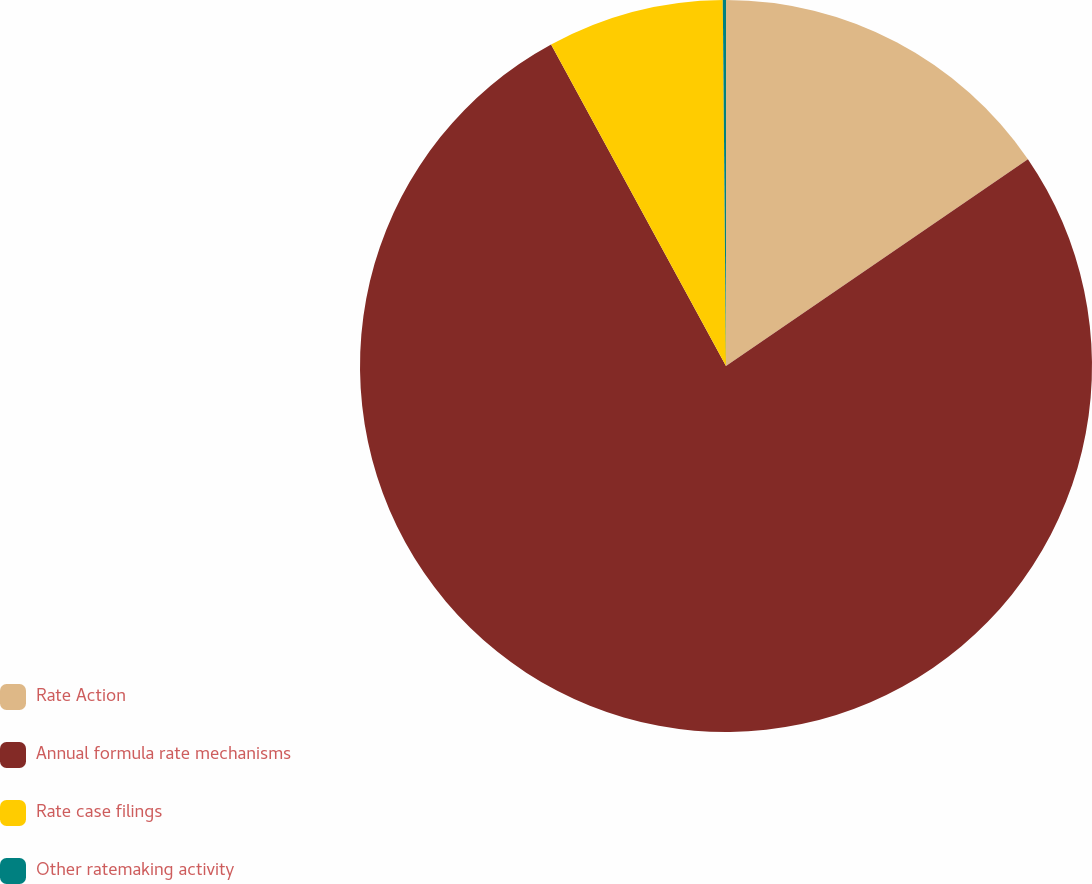Convert chart. <chart><loc_0><loc_0><loc_500><loc_500><pie_chart><fcel>Rate Action<fcel>Annual formula rate mechanisms<fcel>Rate case filings<fcel>Other ratemaking activity<nl><fcel>15.44%<fcel>76.63%<fcel>7.79%<fcel>0.14%<nl></chart> 